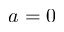<formula> <loc_0><loc_0><loc_500><loc_500>a = 0</formula> 